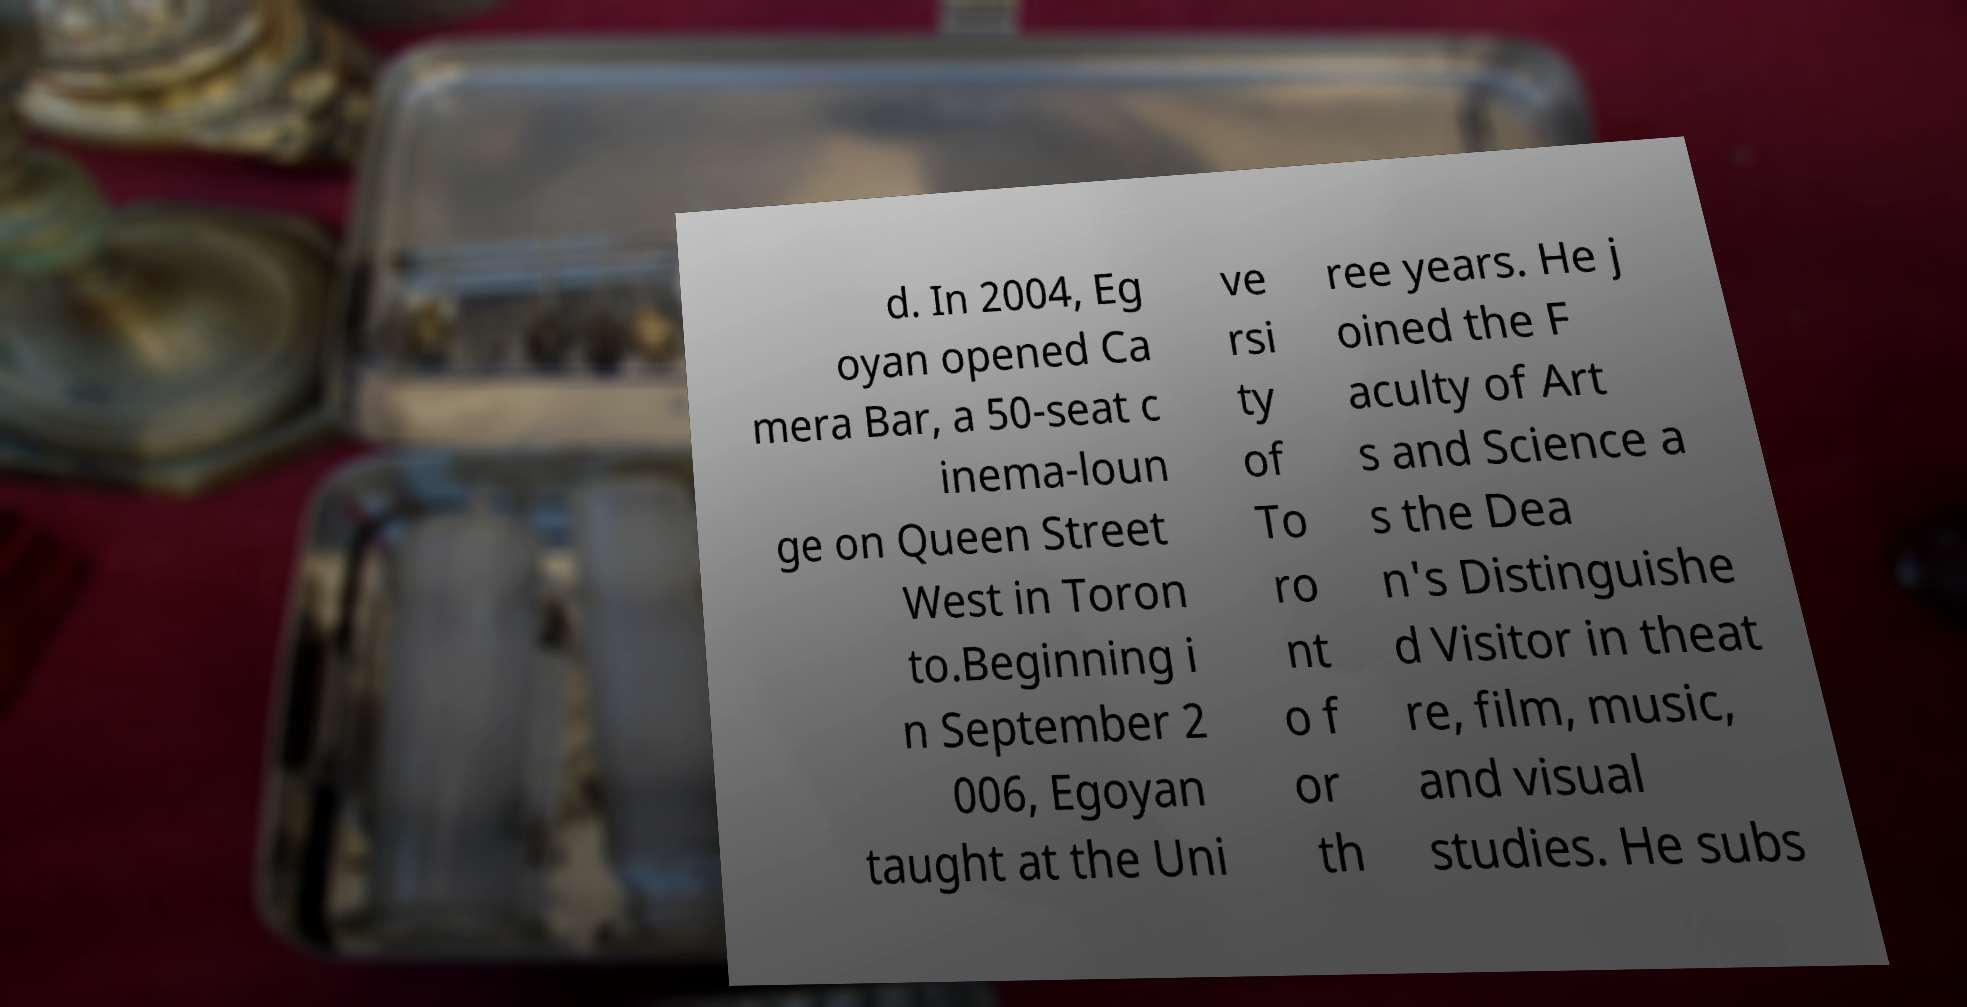For documentation purposes, I need the text within this image transcribed. Could you provide that? d. In 2004, Eg oyan opened Ca mera Bar, a 50-seat c inema-loun ge on Queen Street West in Toron to.Beginning i n September 2 006, Egoyan taught at the Uni ve rsi ty of To ro nt o f or th ree years. He j oined the F aculty of Art s and Science a s the Dea n's Distinguishe d Visitor in theat re, film, music, and visual studies. He subs 